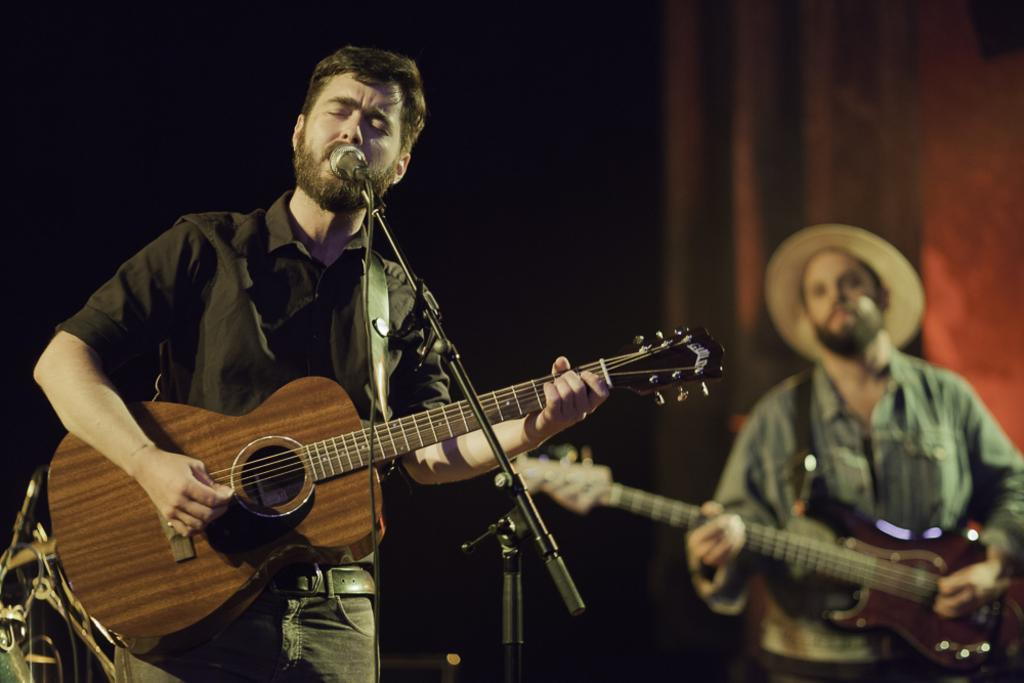What are the two men in the image doing? The two men in the image are playing guitars. How are the guitars being held by the men? The men are holding the guitars in their hands. What is the third man in the image doing? The third man in the image is singing. How is the singer amplifying his voice in the image? The singer is using a microphone. Can you see any bees buzzing around the microphone in the image? There are no bees present in the image. What type of drain is visible in the image? There is no drain present in the image. 